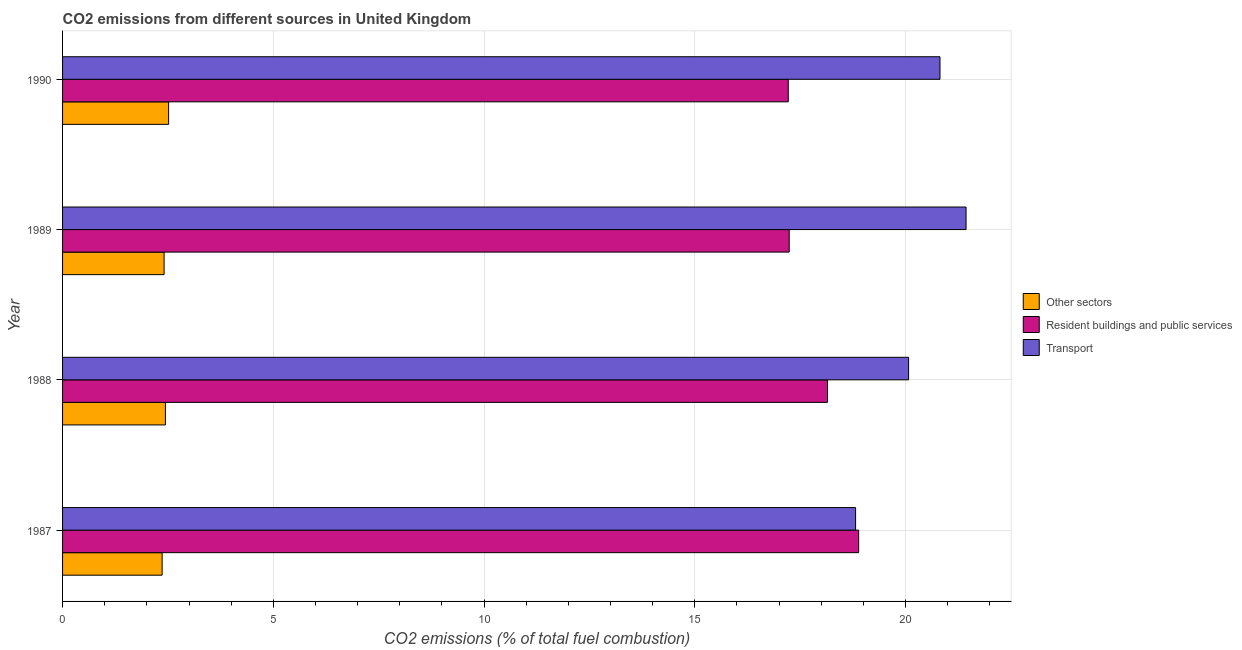Are the number of bars on each tick of the Y-axis equal?
Offer a very short reply. Yes. What is the percentage of co2 emissions from resident buildings and public services in 1988?
Your answer should be very brief. 18.15. Across all years, what is the maximum percentage of co2 emissions from other sectors?
Provide a succinct answer. 2.52. Across all years, what is the minimum percentage of co2 emissions from resident buildings and public services?
Give a very brief answer. 17.22. In which year was the percentage of co2 emissions from transport maximum?
Your answer should be very brief. 1989. In which year was the percentage of co2 emissions from other sectors minimum?
Provide a succinct answer. 1987. What is the total percentage of co2 emissions from transport in the graph?
Ensure brevity in your answer.  81.14. What is the difference between the percentage of co2 emissions from other sectors in 1988 and that in 1989?
Your answer should be very brief. 0.03. What is the difference between the percentage of co2 emissions from transport in 1987 and the percentage of co2 emissions from resident buildings and public services in 1989?
Offer a terse response. 1.58. What is the average percentage of co2 emissions from transport per year?
Give a very brief answer. 20.29. In the year 1989, what is the difference between the percentage of co2 emissions from transport and percentage of co2 emissions from resident buildings and public services?
Provide a short and direct response. 4.2. In how many years, is the percentage of co2 emissions from transport greater than 8 %?
Provide a succinct answer. 4. What is the ratio of the percentage of co2 emissions from transport in 1987 to that in 1988?
Ensure brevity in your answer.  0.94. Is the percentage of co2 emissions from resident buildings and public services in 1988 less than that in 1989?
Your answer should be compact. No. What is the difference between the highest and the second highest percentage of co2 emissions from transport?
Offer a terse response. 0.62. What is the difference between the highest and the lowest percentage of co2 emissions from other sectors?
Keep it short and to the point. 0.15. What does the 3rd bar from the top in 1989 represents?
Your answer should be very brief. Other sectors. What does the 1st bar from the bottom in 1988 represents?
Provide a short and direct response. Other sectors. Are all the bars in the graph horizontal?
Your response must be concise. Yes. Are the values on the major ticks of X-axis written in scientific E-notation?
Your answer should be very brief. No. How many legend labels are there?
Offer a very short reply. 3. How are the legend labels stacked?
Keep it short and to the point. Vertical. What is the title of the graph?
Offer a terse response. CO2 emissions from different sources in United Kingdom. What is the label or title of the X-axis?
Your answer should be compact. CO2 emissions (% of total fuel combustion). What is the CO2 emissions (% of total fuel combustion) of Other sectors in 1987?
Ensure brevity in your answer.  2.36. What is the CO2 emissions (% of total fuel combustion) of Resident buildings and public services in 1987?
Ensure brevity in your answer.  18.89. What is the CO2 emissions (% of total fuel combustion) in Transport in 1987?
Give a very brief answer. 18.82. What is the CO2 emissions (% of total fuel combustion) of Other sectors in 1988?
Keep it short and to the point. 2.44. What is the CO2 emissions (% of total fuel combustion) of Resident buildings and public services in 1988?
Provide a succinct answer. 18.15. What is the CO2 emissions (% of total fuel combustion) in Transport in 1988?
Your answer should be compact. 20.07. What is the CO2 emissions (% of total fuel combustion) in Other sectors in 1989?
Your answer should be very brief. 2.41. What is the CO2 emissions (% of total fuel combustion) of Resident buildings and public services in 1989?
Provide a short and direct response. 17.24. What is the CO2 emissions (% of total fuel combustion) of Transport in 1989?
Keep it short and to the point. 21.44. What is the CO2 emissions (% of total fuel combustion) in Other sectors in 1990?
Offer a terse response. 2.52. What is the CO2 emissions (% of total fuel combustion) of Resident buildings and public services in 1990?
Provide a succinct answer. 17.22. What is the CO2 emissions (% of total fuel combustion) in Transport in 1990?
Keep it short and to the point. 20.82. Across all years, what is the maximum CO2 emissions (% of total fuel combustion) in Other sectors?
Make the answer very short. 2.52. Across all years, what is the maximum CO2 emissions (% of total fuel combustion) in Resident buildings and public services?
Your response must be concise. 18.89. Across all years, what is the maximum CO2 emissions (% of total fuel combustion) of Transport?
Your response must be concise. 21.44. Across all years, what is the minimum CO2 emissions (% of total fuel combustion) in Other sectors?
Provide a succinct answer. 2.36. Across all years, what is the minimum CO2 emissions (% of total fuel combustion) in Resident buildings and public services?
Give a very brief answer. 17.22. Across all years, what is the minimum CO2 emissions (% of total fuel combustion) in Transport?
Ensure brevity in your answer.  18.82. What is the total CO2 emissions (% of total fuel combustion) of Other sectors in the graph?
Provide a short and direct response. 9.73. What is the total CO2 emissions (% of total fuel combustion) in Resident buildings and public services in the graph?
Ensure brevity in your answer.  71.5. What is the total CO2 emissions (% of total fuel combustion) in Transport in the graph?
Your response must be concise. 81.14. What is the difference between the CO2 emissions (% of total fuel combustion) of Other sectors in 1987 and that in 1988?
Your response must be concise. -0.08. What is the difference between the CO2 emissions (% of total fuel combustion) in Resident buildings and public services in 1987 and that in 1988?
Your answer should be very brief. 0.74. What is the difference between the CO2 emissions (% of total fuel combustion) in Transport in 1987 and that in 1988?
Keep it short and to the point. -1.26. What is the difference between the CO2 emissions (% of total fuel combustion) in Other sectors in 1987 and that in 1989?
Give a very brief answer. -0.05. What is the difference between the CO2 emissions (% of total fuel combustion) in Resident buildings and public services in 1987 and that in 1989?
Ensure brevity in your answer.  1.65. What is the difference between the CO2 emissions (% of total fuel combustion) in Transport in 1987 and that in 1989?
Ensure brevity in your answer.  -2.62. What is the difference between the CO2 emissions (% of total fuel combustion) in Other sectors in 1987 and that in 1990?
Your answer should be compact. -0.15. What is the difference between the CO2 emissions (% of total fuel combustion) of Resident buildings and public services in 1987 and that in 1990?
Your response must be concise. 1.67. What is the difference between the CO2 emissions (% of total fuel combustion) in Transport in 1987 and that in 1990?
Your answer should be very brief. -2. What is the difference between the CO2 emissions (% of total fuel combustion) in Other sectors in 1988 and that in 1989?
Provide a succinct answer. 0.03. What is the difference between the CO2 emissions (% of total fuel combustion) in Resident buildings and public services in 1988 and that in 1989?
Make the answer very short. 0.91. What is the difference between the CO2 emissions (% of total fuel combustion) in Transport in 1988 and that in 1989?
Provide a succinct answer. -1.36. What is the difference between the CO2 emissions (% of total fuel combustion) of Other sectors in 1988 and that in 1990?
Make the answer very short. -0.08. What is the difference between the CO2 emissions (% of total fuel combustion) in Resident buildings and public services in 1988 and that in 1990?
Give a very brief answer. 0.93. What is the difference between the CO2 emissions (% of total fuel combustion) in Transport in 1988 and that in 1990?
Your answer should be compact. -0.74. What is the difference between the CO2 emissions (% of total fuel combustion) in Other sectors in 1989 and that in 1990?
Provide a short and direct response. -0.11. What is the difference between the CO2 emissions (% of total fuel combustion) of Resident buildings and public services in 1989 and that in 1990?
Your answer should be very brief. 0.02. What is the difference between the CO2 emissions (% of total fuel combustion) of Transport in 1989 and that in 1990?
Provide a succinct answer. 0.62. What is the difference between the CO2 emissions (% of total fuel combustion) in Other sectors in 1987 and the CO2 emissions (% of total fuel combustion) in Resident buildings and public services in 1988?
Your answer should be compact. -15.79. What is the difference between the CO2 emissions (% of total fuel combustion) of Other sectors in 1987 and the CO2 emissions (% of total fuel combustion) of Transport in 1988?
Provide a succinct answer. -17.71. What is the difference between the CO2 emissions (% of total fuel combustion) of Resident buildings and public services in 1987 and the CO2 emissions (% of total fuel combustion) of Transport in 1988?
Ensure brevity in your answer.  -1.18. What is the difference between the CO2 emissions (% of total fuel combustion) in Other sectors in 1987 and the CO2 emissions (% of total fuel combustion) in Resident buildings and public services in 1989?
Your answer should be compact. -14.88. What is the difference between the CO2 emissions (% of total fuel combustion) of Other sectors in 1987 and the CO2 emissions (% of total fuel combustion) of Transport in 1989?
Provide a succinct answer. -19.07. What is the difference between the CO2 emissions (% of total fuel combustion) in Resident buildings and public services in 1987 and the CO2 emissions (% of total fuel combustion) in Transport in 1989?
Offer a very short reply. -2.55. What is the difference between the CO2 emissions (% of total fuel combustion) in Other sectors in 1987 and the CO2 emissions (% of total fuel combustion) in Resident buildings and public services in 1990?
Keep it short and to the point. -14.86. What is the difference between the CO2 emissions (% of total fuel combustion) of Other sectors in 1987 and the CO2 emissions (% of total fuel combustion) of Transport in 1990?
Give a very brief answer. -18.46. What is the difference between the CO2 emissions (% of total fuel combustion) in Resident buildings and public services in 1987 and the CO2 emissions (% of total fuel combustion) in Transport in 1990?
Ensure brevity in your answer.  -1.93. What is the difference between the CO2 emissions (% of total fuel combustion) of Other sectors in 1988 and the CO2 emissions (% of total fuel combustion) of Resident buildings and public services in 1989?
Keep it short and to the point. -14.8. What is the difference between the CO2 emissions (% of total fuel combustion) of Other sectors in 1988 and the CO2 emissions (% of total fuel combustion) of Transport in 1989?
Make the answer very short. -19. What is the difference between the CO2 emissions (% of total fuel combustion) of Resident buildings and public services in 1988 and the CO2 emissions (% of total fuel combustion) of Transport in 1989?
Ensure brevity in your answer.  -3.29. What is the difference between the CO2 emissions (% of total fuel combustion) of Other sectors in 1988 and the CO2 emissions (% of total fuel combustion) of Resident buildings and public services in 1990?
Your answer should be compact. -14.78. What is the difference between the CO2 emissions (% of total fuel combustion) in Other sectors in 1988 and the CO2 emissions (% of total fuel combustion) in Transport in 1990?
Make the answer very short. -18.38. What is the difference between the CO2 emissions (% of total fuel combustion) in Resident buildings and public services in 1988 and the CO2 emissions (% of total fuel combustion) in Transport in 1990?
Make the answer very short. -2.67. What is the difference between the CO2 emissions (% of total fuel combustion) in Other sectors in 1989 and the CO2 emissions (% of total fuel combustion) in Resident buildings and public services in 1990?
Your answer should be compact. -14.81. What is the difference between the CO2 emissions (% of total fuel combustion) in Other sectors in 1989 and the CO2 emissions (% of total fuel combustion) in Transport in 1990?
Give a very brief answer. -18.41. What is the difference between the CO2 emissions (% of total fuel combustion) in Resident buildings and public services in 1989 and the CO2 emissions (% of total fuel combustion) in Transport in 1990?
Ensure brevity in your answer.  -3.58. What is the average CO2 emissions (% of total fuel combustion) in Other sectors per year?
Ensure brevity in your answer.  2.43. What is the average CO2 emissions (% of total fuel combustion) of Resident buildings and public services per year?
Your answer should be very brief. 17.87. What is the average CO2 emissions (% of total fuel combustion) in Transport per year?
Offer a terse response. 20.29. In the year 1987, what is the difference between the CO2 emissions (% of total fuel combustion) in Other sectors and CO2 emissions (% of total fuel combustion) in Resident buildings and public services?
Your answer should be compact. -16.53. In the year 1987, what is the difference between the CO2 emissions (% of total fuel combustion) in Other sectors and CO2 emissions (% of total fuel combustion) in Transport?
Keep it short and to the point. -16.45. In the year 1987, what is the difference between the CO2 emissions (% of total fuel combustion) of Resident buildings and public services and CO2 emissions (% of total fuel combustion) of Transport?
Your answer should be very brief. 0.07. In the year 1988, what is the difference between the CO2 emissions (% of total fuel combustion) of Other sectors and CO2 emissions (% of total fuel combustion) of Resident buildings and public services?
Your answer should be compact. -15.71. In the year 1988, what is the difference between the CO2 emissions (% of total fuel combustion) of Other sectors and CO2 emissions (% of total fuel combustion) of Transport?
Provide a succinct answer. -17.63. In the year 1988, what is the difference between the CO2 emissions (% of total fuel combustion) of Resident buildings and public services and CO2 emissions (% of total fuel combustion) of Transport?
Offer a very short reply. -1.92. In the year 1989, what is the difference between the CO2 emissions (% of total fuel combustion) in Other sectors and CO2 emissions (% of total fuel combustion) in Resident buildings and public services?
Keep it short and to the point. -14.83. In the year 1989, what is the difference between the CO2 emissions (% of total fuel combustion) of Other sectors and CO2 emissions (% of total fuel combustion) of Transport?
Provide a short and direct response. -19.03. In the year 1989, what is the difference between the CO2 emissions (% of total fuel combustion) in Resident buildings and public services and CO2 emissions (% of total fuel combustion) in Transport?
Your answer should be very brief. -4.2. In the year 1990, what is the difference between the CO2 emissions (% of total fuel combustion) of Other sectors and CO2 emissions (% of total fuel combustion) of Resident buildings and public services?
Provide a succinct answer. -14.7. In the year 1990, what is the difference between the CO2 emissions (% of total fuel combustion) of Other sectors and CO2 emissions (% of total fuel combustion) of Transport?
Your response must be concise. -18.3. In the year 1990, what is the difference between the CO2 emissions (% of total fuel combustion) of Resident buildings and public services and CO2 emissions (% of total fuel combustion) of Transport?
Make the answer very short. -3.6. What is the ratio of the CO2 emissions (% of total fuel combustion) in Other sectors in 1987 to that in 1988?
Keep it short and to the point. 0.97. What is the ratio of the CO2 emissions (% of total fuel combustion) of Resident buildings and public services in 1987 to that in 1988?
Provide a succinct answer. 1.04. What is the ratio of the CO2 emissions (% of total fuel combustion) in Transport in 1987 to that in 1988?
Give a very brief answer. 0.94. What is the ratio of the CO2 emissions (% of total fuel combustion) in Other sectors in 1987 to that in 1989?
Provide a short and direct response. 0.98. What is the ratio of the CO2 emissions (% of total fuel combustion) of Resident buildings and public services in 1987 to that in 1989?
Provide a succinct answer. 1.1. What is the ratio of the CO2 emissions (% of total fuel combustion) in Transport in 1987 to that in 1989?
Give a very brief answer. 0.88. What is the ratio of the CO2 emissions (% of total fuel combustion) of Other sectors in 1987 to that in 1990?
Your answer should be compact. 0.94. What is the ratio of the CO2 emissions (% of total fuel combustion) in Resident buildings and public services in 1987 to that in 1990?
Ensure brevity in your answer.  1.1. What is the ratio of the CO2 emissions (% of total fuel combustion) of Transport in 1987 to that in 1990?
Offer a terse response. 0.9. What is the ratio of the CO2 emissions (% of total fuel combustion) of Other sectors in 1988 to that in 1989?
Your answer should be compact. 1.01. What is the ratio of the CO2 emissions (% of total fuel combustion) of Resident buildings and public services in 1988 to that in 1989?
Ensure brevity in your answer.  1.05. What is the ratio of the CO2 emissions (% of total fuel combustion) in Transport in 1988 to that in 1989?
Offer a terse response. 0.94. What is the ratio of the CO2 emissions (% of total fuel combustion) in Other sectors in 1988 to that in 1990?
Ensure brevity in your answer.  0.97. What is the ratio of the CO2 emissions (% of total fuel combustion) in Resident buildings and public services in 1988 to that in 1990?
Offer a very short reply. 1.05. What is the ratio of the CO2 emissions (% of total fuel combustion) of Transport in 1988 to that in 1990?
Your answer should be very brief. 0.96. What is the ratio of the CO2 emissions (% of total fuel combustion) in Other sectors in 1989 to that in 1990?
Ensure brevity in your answer.  0.96. What is the ratio of the CO2 emissions (% of total fuel combustion) of Resident buildings and public services in 1989 to that in 1990?
Offer a very short reply. 1. What is the ratio of the CO2 emissions (% of total fuel combustion) of Transport in 1989 to that in 1990?
Your answer should be very brief. 1.03. What is the difference between the highest and the second highest CO2 emissions (% of total fuel combustion) in Other sectors?
Provide a succinct answer. 0.08. What is the difference between the highest and the second highest CO2 emissions (% of total fuel combustion) of Resident buildings and public services?
Your answer should be compact. 0.74. What is the difference between the highest and the second highest CO2 emissions (% of total fuel combustion) in Transport?
Provide a short and direct response. 0.62. What is the difference between the highest and the lowest CO2 emissions (% of total fuel combustion) in Other sectors?
Ensure brevity in your answer.  0.15. What is the difference between the highest and the lowest CO2 emissions (% of total fuel combustion) in Resident buildings and public services?
Ensure brevity in your answer.  1.67. What is the difference between the highest and the lowest CO2 emissions (% of total fuel combustion) in Transport?
Offer a very short reply. 2.62. 